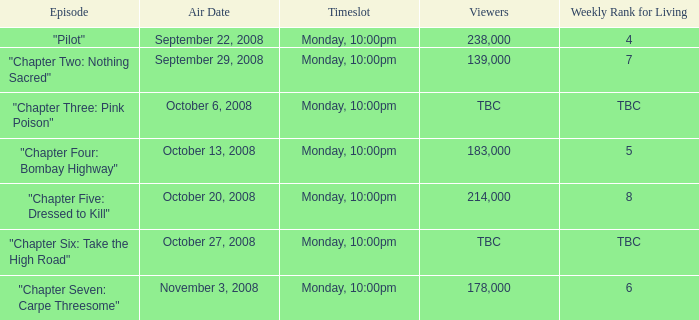What is the weekly rank for living when the air date is october 6, 2008? TBC. 